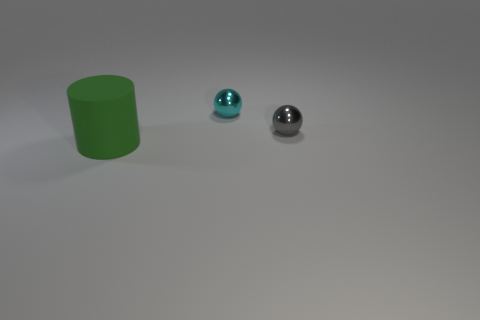Do the gray object and the object that is on the left side of the small cyan object have the same shape?
Provide a short and direct response. No. There is a object that is left of the small gray shiny object and in front of the tiny cyan metallic ball; what size is it?
Keep it short and to the point. Large. The small gray object has what shape?
Your answer should be very brief. Sphere. There is a small shiny ball that is on the left side of the small gray shiny sphere; is there a tiny shiny ball that is in front of it?
Make the answer very short. Yes. There is a ball on the left side of the tiny gray metal ball; what number of cyan spheres are in front of it?
Keep it short and to the point. 0. There is a gray sphere that is the same size as the cyan metallic thing; what is its material?
Your answer should be very brief. Metal. Does the tiny thing to the right of the tiny cyan sphere have the same shape as the rubber thing?
Ensure brevity in your answer.  No. Is the number of spheres on the left side of the small gray shiny thing greater than the number of objects left of the matte thing?
Offer a very short reply. Yes. How many other gray objects are made of the same material as the large object?
Offer a very short reply. 0. Is the cyan object the same size as the green thing?
Ensure brevity in your answer.  No. 